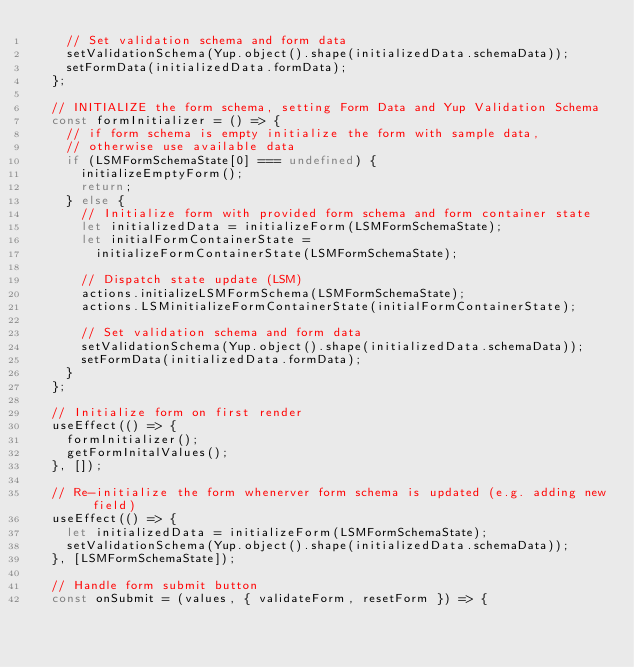Convert code to text. <code><loc_0><loc_0><loc_500><loc_500><_JavaScript_>    // Set validation schema and form data
    setValidationSchema(Yup.object().shape(initializedData.schemaData));
    setFormData(initializedData.formData);
  };

  // INITIALIZE the form schema, setting Form Data and Yup Validation Schema
  const formInitializer = () => {
    // if form schema is empty initialize the form with sample data,
    // otherwise use available data
    if (LSMFormSchemaState[0] === undefined) {
      initializeEmptyForm();
      return;
    } else {
      // Initialize form with provided form schema and form container state
      let initializedData = initializeForm(LSMFormSchemaState);
      let initialFormContainerState =
        initializeFormContainerState(LSMFormSchemaState);

      // Dispatch state update (LSM)
      actions.initializeLSMFormSchema(LSMFormSchemaState);
      actions.LSMinitializeFormContainerState(initialFormContainerState);

      // Set validation schema and form data
      setValidationSchema(Yup.object().shape(initializedData.schemaData));
      setFormData(initializedData.formData);
    }
  };

  // Initialize form on first render
  useEffect(() => {
    formInitializer();
    getFormInitalValues();
  }, []);

  // Re-initialize the form whenerver form schema is updated (e.g. adding new field)
  useEffect(() => {
    let initializedData = initializeForm(LSMFormSchemaState);
    setValidationSchema(Yup.object().shape(initializedData.schemaData));
  }, [LSMFormSchemaState]);

  // Handle form submit button
  const onSubmit = (values, { validateForm, resetForm }) => {</code> 